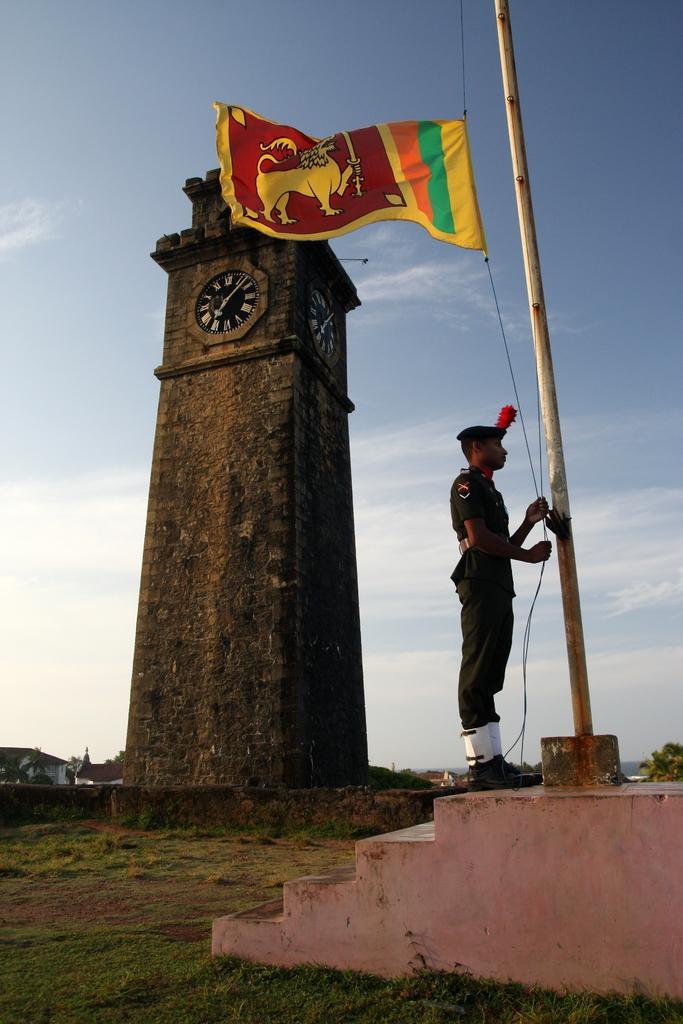In one or two sentences, can you explain what this image depicts? In the foreground of this image, on the right, there is a man hoisting a flag. We can also see stairs and grass. Behind it, there is a clock tower, few buildings and the sky. 